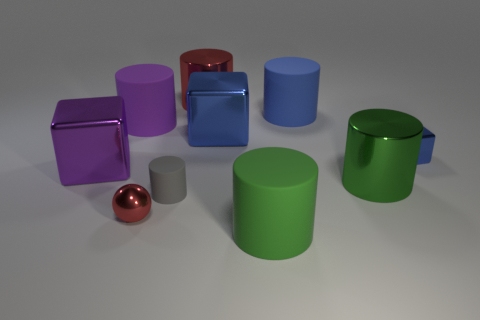Subtract all big purple cylinders. How many cylinders are left? 5 Subtract all red cylinders. How many blue cubes are left? 2 Subtract all blue cylinders. How many cylinders are left? 5 Subtract 2 cylinders. How many cylinders are left? 4 Subtract all blocks. How many objects are left? 7 Add 7 small brown matte blocks. How many small brown matte blocks exist? 7 Subtract 0 brown blocks. How many objects are left? 10 Subtract all brown balls. Subtract all blue cubes. How many balls are left? 1 Subtract all tiny blue rubber things. Subtract all small red metal things. How many objects are left? 9 Add 8 balls. How many balls are left? 9 